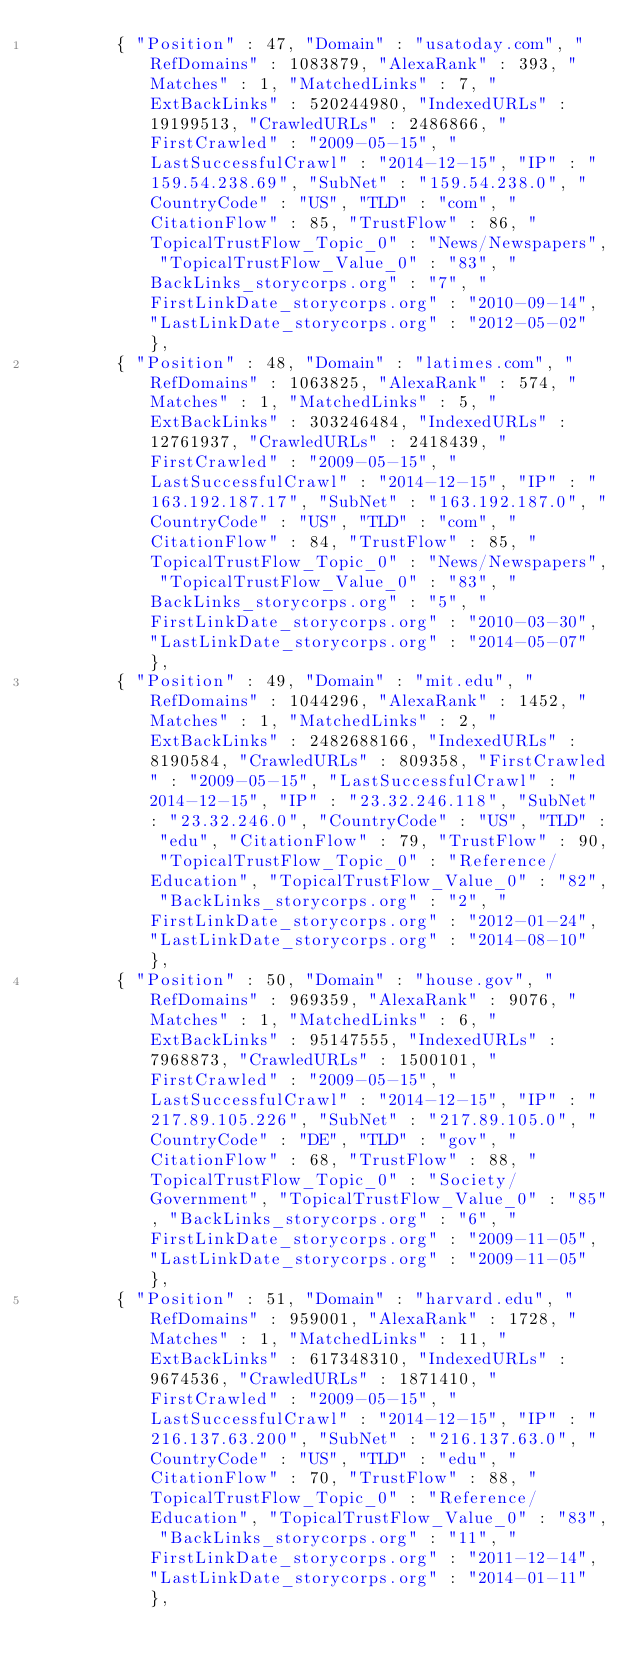Convert code to text. <code><loc_0><loc_0><loc_500><loc_500><_XML_>				{ "Position" : 47, "Domain" : "usatoday.com", "RefDomains" : 1083879, "AlexaRank" : 393, "Matches" : 1, "MatchedLinks" : 7, "ExtBackLinks" : 520244980, "IndexedURLs" : 19199513, "CrawledURLs" : 2486866, "FirstCrawled" : "2009-05-15", "LastSuccessfulCrawl" : "2014-12-15", "IP" : "159.54.238.69", "SubNet" : "159.54.238.0", "CountryCode" : "US", "TLD" : "com", "CitationFlow" : 85, "TrustFlow" : 86, "TopicalTrustFlow_Topic_0" : "News/Newspapers", "TopicalTrustFlow_Value_0" : "83", "BackLinks_storycorps.org" : "7", "FirstLinkDate_storycorps.org" : "2010-09-14", "LastLinkDate_storycorps.org" : "2012-05-02" },
				{ "Position" : 48, "Domain" : "latimes.com", "RefDomains" : 1063825, "AlexaRank" : 574, "Matches" : 1, "MatchedLinks" : 5, "ExtBackLinks" : 303246484, "IndexedURLs" : 12761937, "CrawledURLs" : 2418439, "FirstCrawled" : "2009-05-15", "LastSuccessfulCrawl" : "2014-12-15", "IP" : "163.192.187.17", "SubNet" : "163.192.187.0", "CountryCode" : "US", "TLD" : "com", "CitationFlow" : 84, "TrustFlow" : 85, "TopicalTrustFlow_Topic_0" : "News/Newspapers", "TopicalTrustFlow_Value_0" : "83", "BackLinks_storycorps.org" : "5", "FirstLinkDate_storycorps.org" : "2010-03-30", "LastLinkDate_storycorps.org" : "2014-05-07" },
				{ "Position" : 49, "Domain" : "mit.edu", "RefDomains" : 1044296, "AlexaRank" : 1452, "Matches" : 1, "MatchedLinks" : 2, "ExtBackLinks" : 2482688166, "IndexedURLs" : 8190584, "CrawledURLs" : 809358, "FirstCrawled" : "2009-05-15", "LastSuccessfulCrawl" : "2014-12-15", "IP" : "23.32.246.118", "SubNet" : "23.32.246.0", "CountryCode" : "US", "TLD" : "edu", "CitationFlow" : 79, "TrustFlow" : 90, "TopicalTrustFlow_Topic_0" : "Reference/Education", "TopicalTrustFlow_Value_0" : "82", "BackLinks_storycorps.org" : "2", "FirstLinkDate_storycorps.org" : "2012-01-24", "LastLinkDate_storycorps.org" : "2014-08-10" },
				{ "Position" : 50, "Domain" : "house.gov", "RefDomains" : 969359, "AlexaRank" : 9076, "Matches" : 1, "MatchedLinks" : 6, "ExtBackLinks" : 95147555, "IndexedURLs" : 7968873, "CrawledURLs" : 1500101, "FirstCrawled" : "2009-05-15", "LastSuccessfulCrawl" : "2014-12-15", "IP" : "217.89.105.226", "SubNet" : "217.89.105.0", "CountryCode" : "DE", "TLD" : "gov", "CitationFlow" : 68, "TrustFlow" : 88, "TopicalTrustFlow_Topic_0" : "Society/Government", "TopicalTrustFlow_Value_0" : "85", "BackLinks_storycorps.org" : "6", "FirstLinkDate_storycorps.org" : "2009-11-05", "LastLinkDate_storycorps.org" : "2009-11-05" },
				{ "Position" : 51, "Domain" : "harvard.edu", "RefDomains" : 959001, "AlexaRank" : 1728, "Matches" : 1, "MatchedLinks" : 11, "ExtBackLinks" : 617348310, "IndexedURLs" : 9674536, "CrawledURLs" : 1871410, "FirstCrawled" : "2009-05-15", "LastSuccessfulCrawl" : "2014-12-15", "IP" : "216.137.63.200", "SubNet" : "216.137.63.0", "CountryCode" : "US", "TLD" : "edu", "CitationFlow" : 70, "TrustFlow" : 88, "TopicalTrustFlow_Topic_0" : "Reference/Education", "TopicalTrustFlow_Value_0" : "83", "BackLinks_storycorps.org" : "11", "FirstLinkDate_storycorps.org" : "2011-12-14", "LastLinkDate_storycorps.org" : "2014-01-11" },</code> 